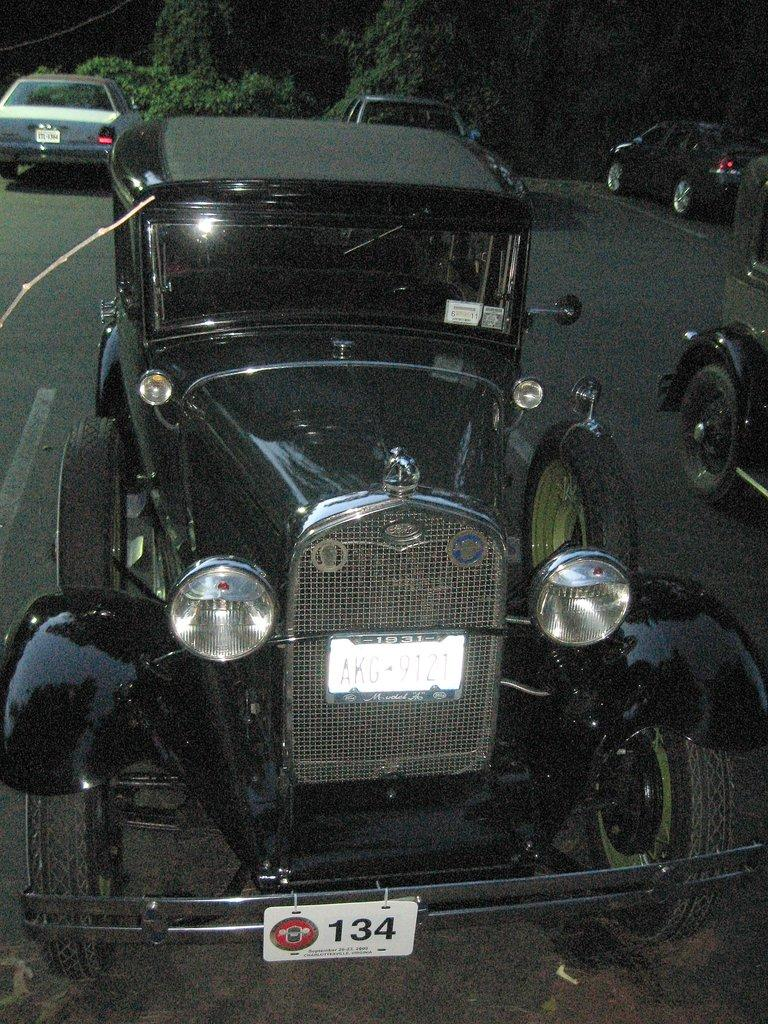What type of vehicle is the main subject of the image? There is a jeep in the image. What distinguishes the jeep from other vehicles? The jeep has a number plate. What can be seen in the background of the image? There are many vehicles and trees visible in the background of the image. What type of wool is used to make the curtain in the image? There is no curtain present in the image. What season is depicted in the image, given the presence of spring flowers? There is no mention of spring flowers or any seasonal elements in the image. 